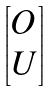<formula> <loc_0><loc_0><loc_500><loc_500>\begin{bmatrix} O \\ U \end{bmatrix}</formula> 